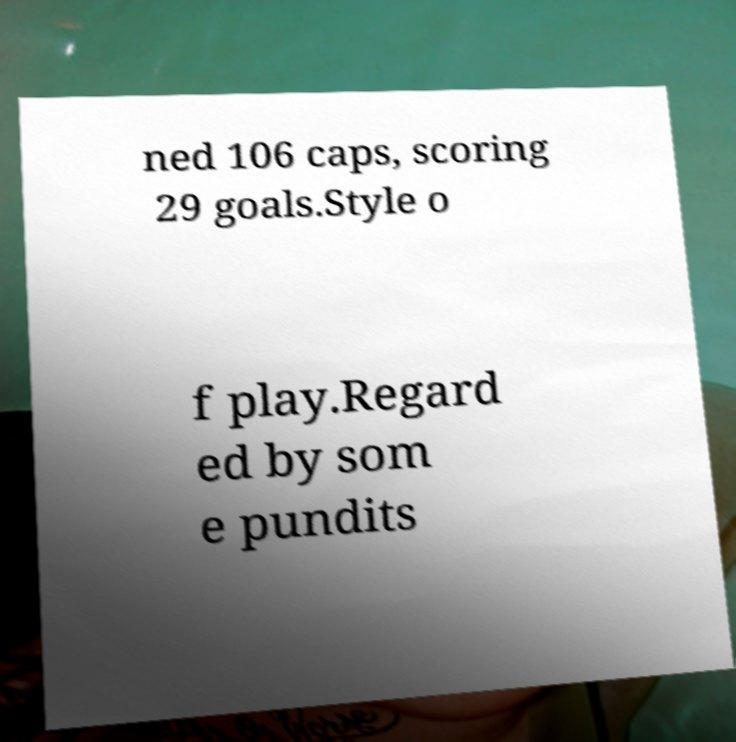There's text embedded in this image that I need extracted. Can you transcribe it verbatim? ned 106 caps, scoring 29 goals.Style o f play.Regard ed by som e pundits 